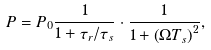Convert formula to latex. <formula><loc_0><loc_0><loc_500><loc_500>P = P _ { 0 } \frac { 1 } { 1 + \tau _ { r } / \tau _ { s } } \cdot \frac { 1 } { 1 + \left ( \Omega T _ { s } \right ) ^ { 2 } } ,</formula> 